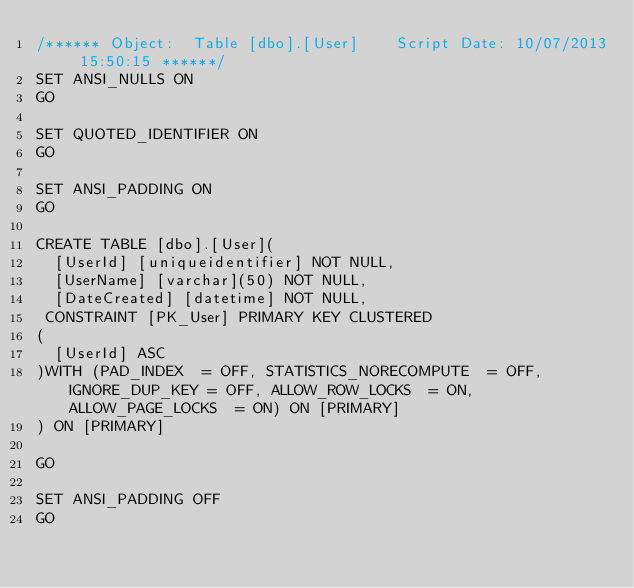Convert code to text. <code><loc_0><loc_0><loc_500><loc_500><_SQL_>/****** Object:  Table [dbo].[User]    Script Date: 10/07/2013 15:50:15 ******/
SET ANSI_NULLS ON
GO

SET QUOTED_IDENTIFIER ON
GO

SET ANSI_PADDING ON
GO

CREATE TABLE [dbo].[User](
	[UserId] [uniqueidentifier] NOT NULL,
	[UserName] [varchar](50) NOT NULL,
	[DateCreated] [datetime] NOT NULL,
 CONSTRAINT [PK_User] PRIMARY KEY CLUSTERED 
(
	[UserId] ASC
)WITH (PAD_INDEX  = OFF, STATISTICS_NORECOMPUTE  = OFF, IGNORE_DUP_KEY = OFF, ALLOW_ROW_LOCKS  = ON, ALLOW_PAGE_LOCKS  = ON) ON [PRIMARY]
) ON [PRIMARY]

GO

SET ANSI_PADDING OFF
GO


</code> 